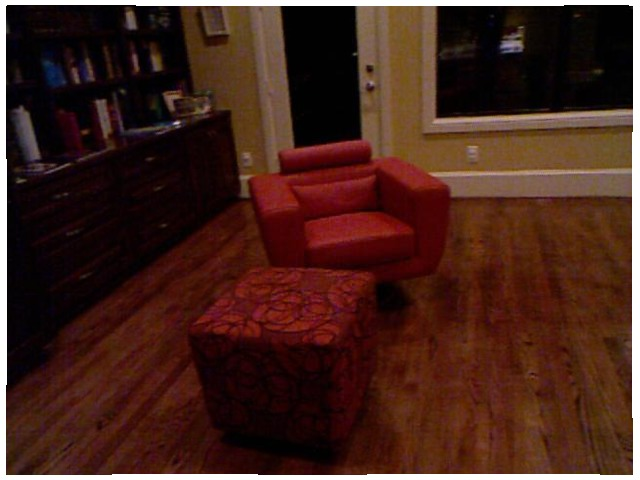<image>
Is there a book on the floor? No. The book is not positioned on the floor. They may be near each other, but the book is not supported by or resting on top of the floor. Is there a window in the chair? No. The window is not contained within the chair. These objects have a different spatial relationship. 